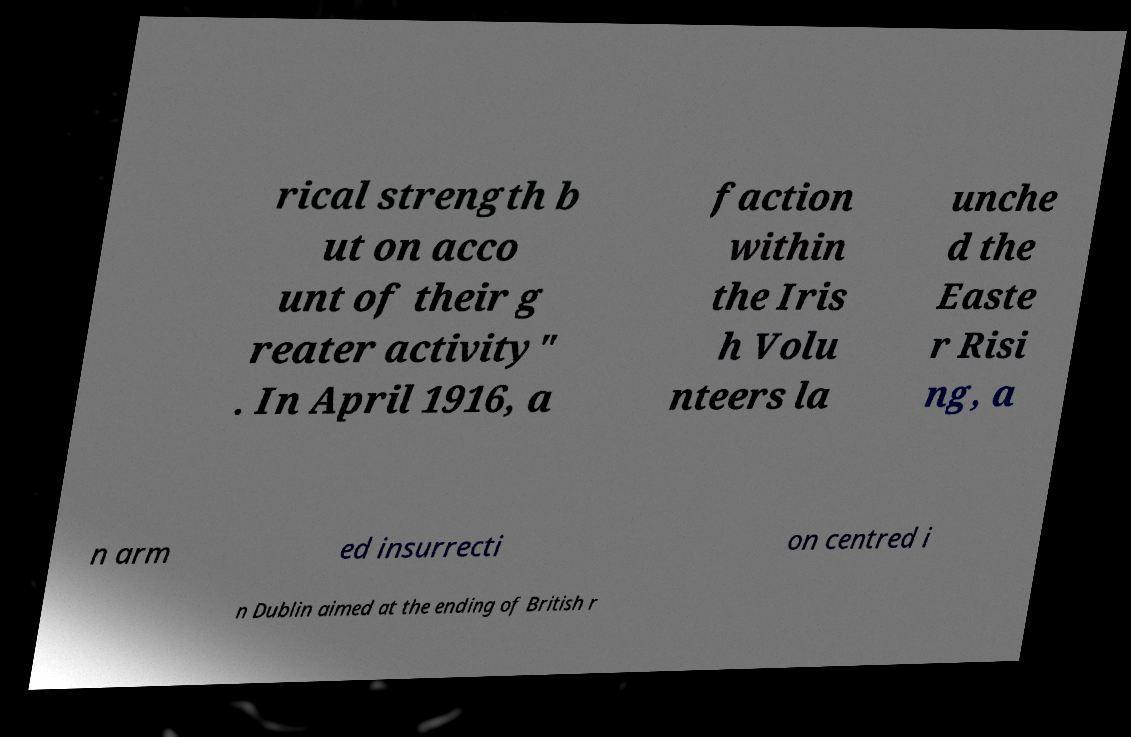Could you extract and type out the text from this image? rical strength b ut on acco unt of their g reater activity" . In April 1916, a faction within the Iris h Volu nteers la unche d the Easte r Risi ng, a n arm ed insurrecti on centred i n Dublin aimed at the ending of British r 